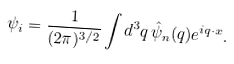Convert formula to latex. <formula><loc_0><loc_0><loc_500><loc_500>\psi _ { i } = \frac { 1 } { ( 2 \pi ) ^ { 3 / 2 } } \int d ^ { 3 } q \, \hat { \psi } _ { n } ( { q } ) e ^ { i { q } \cdot { x } } .</formula> 